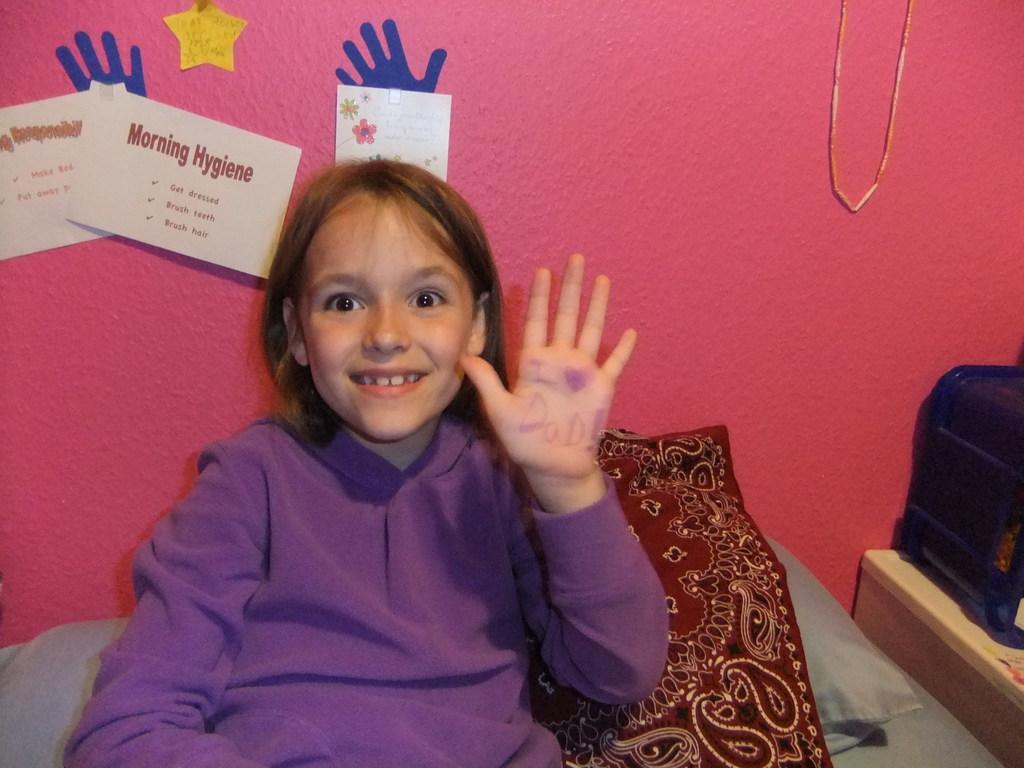Can you describe this image briefly? Here I can see a girl wearing a t-shirt, smiling and sitting on a bed. Beside her I can see few pillows. On the right side a blue color object is placed on a table. At the back of her there is a wall and few papers are attached to this wall. 